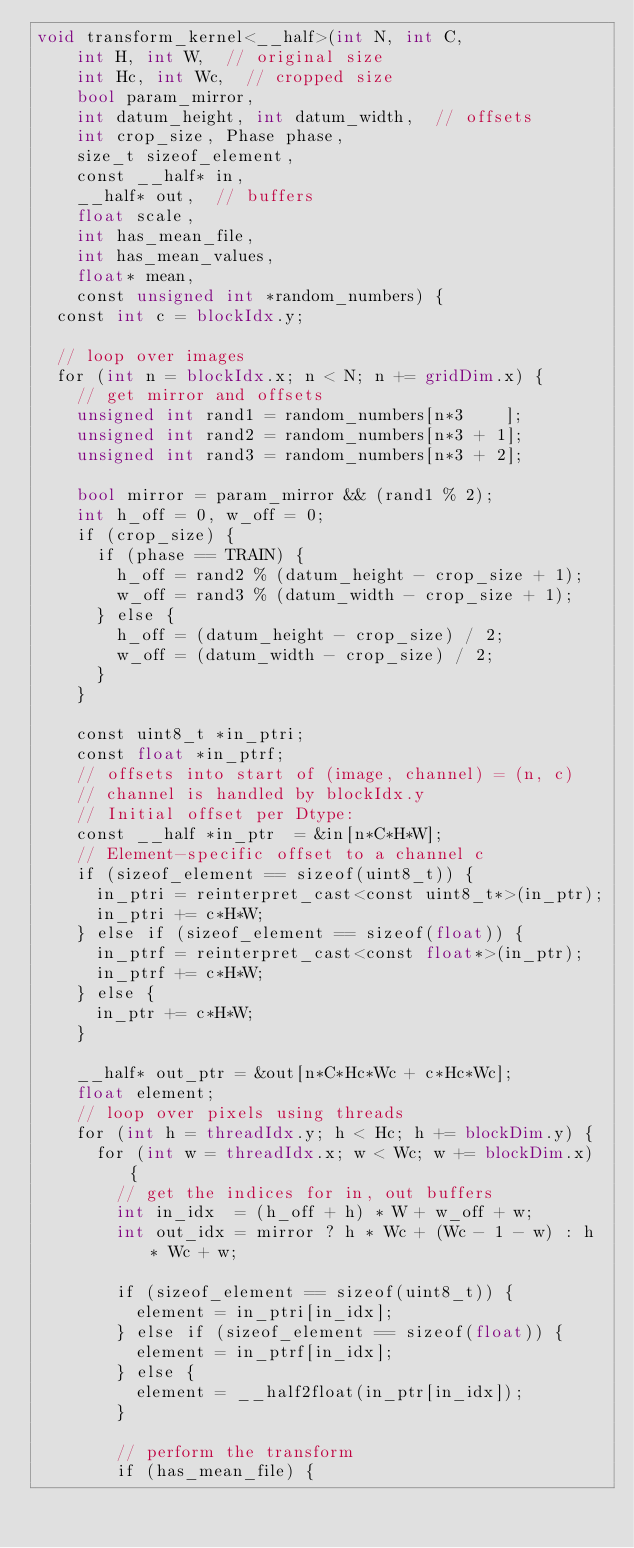Convert code to text. <code><loc_0><loc_0><loc_500><loc_500><_Cuda_>void transform_kernel<__half>(int N, int C,
    int H, int W,  // original size
    int Hc, int Wc,  // cropped size
    bool param_mirror,
    int datum_height, int datum_width,  // offsets
    int crop_size, Phase phase,
    size_t sizeof_element,
    const __half* in,
    __half* out,  // buffers
    float scale,
    int has_mean_file,
    int has_mean_values,
    float* mean,
    const unsigned int *random_numbers) {
  const int c = blockIdx.y;

  // loop over images
  for (int n = blockIdx.x; n < N; n += gridDim.x) {
    // get mirror and offsets
    unsigned int rand1 = random_numbers[n*3    ];
    unsigned int rand2 = random_numbers[n*3 + 1];
    unsigned int rand3 = random_numbers[n*3 + 2];

    bool mirror = param_mirror && (rand1 % 2);
    int h_off = 0, w_off = 0;
    if (crop_size) {
      if (phase == TRAIN) {
        h_off = rand2 % (datum_height - crop_size + 1);
        w_off = rand3 % (datum_width - crop_size + 1);
      } else {
        h_off = (datum_height - crop_size) / 2;
        w_off = (datum_width - crop_size) / 2;
      }
    }

    const uint8_t *in_ptri;
    const float *in_ptrf;
    // offsets into start of (image, channel) = (n, c)
    // channel is handled by blockIdx.y
    // Initial offset per Dtype:
    const __half *in_ptr  = &in[n*C*H*W];
    // Element-specific offset to a channel c
    if (sizeof_element == sizeof(uint8_t)) {
      in_ptri = reinterpret_cast<const uint8_t*>(in_ptr);
      in_ptri += c*H*W;
    } else if (sizeof_element == sizeof(float)) {
      in_ptrf = reinterpret_cast<const float*>(in_ptr);
      in_ptrf += c*H*W;
    } else {
      in_ptr += c*H*W;
    }

    __half* out_ptr = &out[n*C*Hc*Wc + c*Hc*Wc];
    float element;
    // loop over pixels using threads
    for (int h = threadIdx.y; h < Hc; h += blockDim.y) {
      for (int w = threadIdx.x; w < Wc; w += blockDim.x) {
        // get the indices for in, out buffers
        int in_idx  = (h_off + h) * W + w_off + w;
        int out_idx = mirror ? h * Wc + (Wc - 1 - w) : h * Wc + w;

        if (sizeof_element == sizeof(uint8_t)) {
          element = in_ptri[in_idx];
        } else if (sizeof_element == sizeof(float)) {
          element = in_ptrf[in_idx];
        } else {
          element = __half2float(in_ptr[in_idx]);
        }

        // perform the transform
        if (has_mean_file) {</code> 